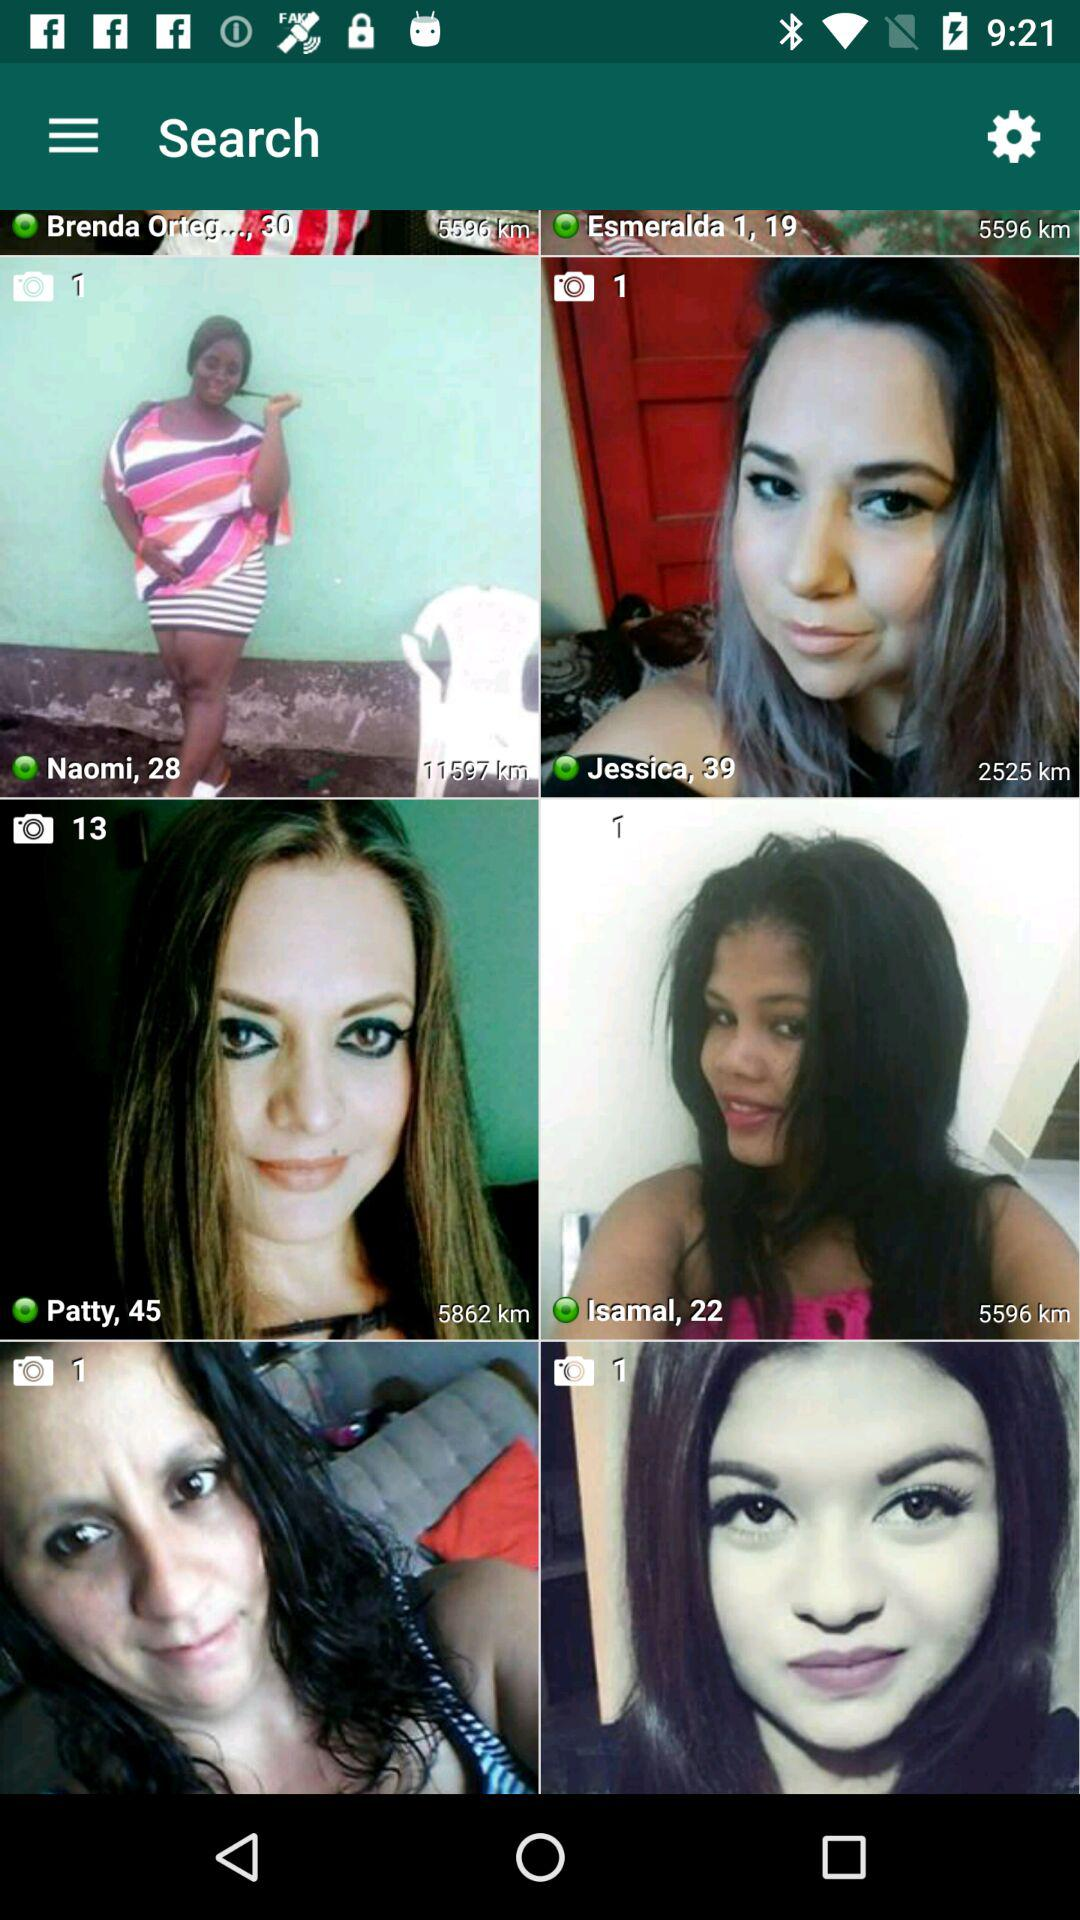What is the age of Isamal? Isamal is 22 years old. 